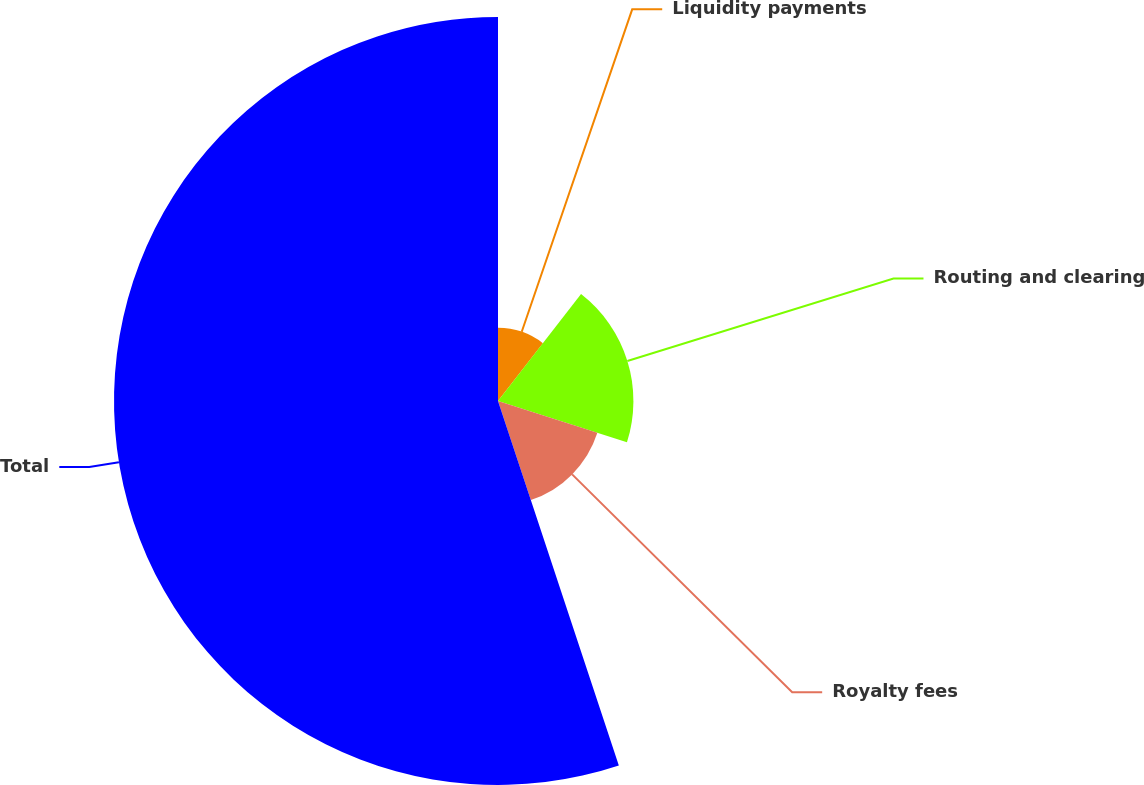<chart> <loc_0><loc_0><loc_500><loc_500><pie_chart><fcel>Liquidity payments<fcel>Routing and clearing<fcel>Royalty fees<fcel>Total<nl><fcel>10.51%<fcel>19.43%<fcel>14.97%<fcel>55.1%<nl></chart> 